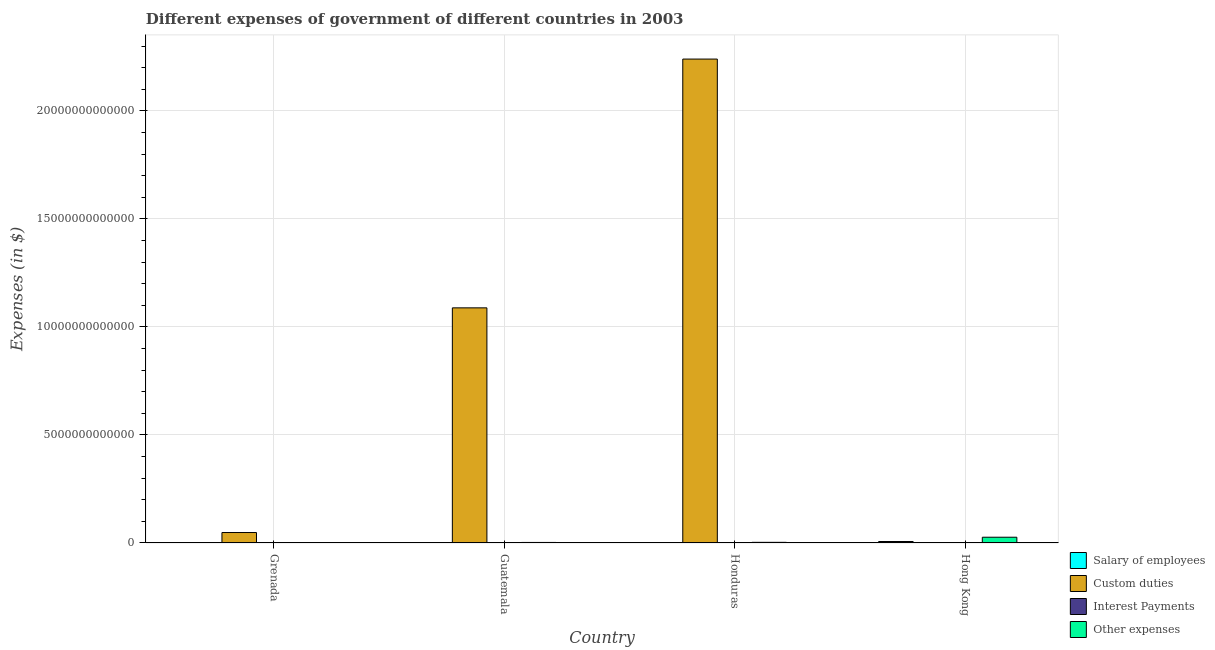How many groups of bars are there?
Offer a very short reply. 4. How many bars are there on the 3rd tick from the left?
Your response must be concise. 4. What is the label of the 4th group of bars from the left?
Ensure brevity in your answer.  Hong Kong. What is the amount spent on other expenses in Grenada?
Provide a succinct answer. 2.86e+08. Across all countries, what is the maximum amount spent on interest payments?
Provide a succinct answer. 2.21e+09. Across all countries, what is the minimum amount spent on other expenses?
Offer a very short reply. 2.86e+08. In which country was the amount spent on custom duties maximum?
Ensure brevity in your answer.  Honduras. In which country was the amount spent on other expenses minimum?
Keep it short and to the point. Grenada. What is the total amount spent on other expenses in the graph?
Offer a terse response. 3.22e+11. What is the difference between the amount spent on custom duties in Honduras and that in Hong Kong?
Give a very brief answer. 2.24e+13. What is the difference between the amount spent on interest payments in Hong Kong and the amount spent on custom duties in Guatemala?
Offer a very short reply. -1.09e+13. What is the average amount spent on other expenses per country?
Give a very brief answer. 8.05e+1. What is the difference between the amount spent on interest payments and amount spent on custom duties in Hong Kong?
Your answer should be very brief. 1.05e+07. What is the ratio of the amount spent on other expenses in Grenada to that in Guatemala?
Provide a succinct answer. 0.01. Is the amount spent on other expenses in Grenada less than that in Guatemala?
Offer a terse response. Yes. Is the difference between the amount spent on custom duties in Guatemala and Hong Kong greater than the difference between the amount spent on salary of employees in Guatemala and Hong Kong?
Your response must be concise. Yes. What is the difference between the highest and the second highest amount spent on custom duties?
Ensure brevity in your answer.  1.15e+13. What is the difference between the highest and the lowest amount spent on salary of employees?
Make the answer very short. 6.86e+1. What does the 3rd bar from the left in Honduras represents?
Your answer should be compact. Interest Payments. What does the 1st bar from the right in Hong Kong represents?
Ensure brevity in your answer.  Other expenses. Are all the bars in the graph horizontal?
Offer a very short reply. No. How many countries are there in the graph?
Your answer should be very brief. 4. What is the difference between two consecutive major ticks on the Y-axis?
Your answer should be compact. 5.00e+12. Are the values on the major ticks of Y-axis written in scientific E-notation?
Your answer should be very brief. No. Does the graph contain grids?
Offer a very short reply. Yes. Where does the legend appear in the graph?
Provide a succinct answer. Bottom right. How many legend labels are there?
Your response must be concise. 4. What is the title of the graph?
Provide a succinct answer. Different expenses of government of different countries in 2003. What is the label or title of the X-axis?
Your answer should be compact. Country. What is the label or title of the Y-axis?
Give a very brief answer. Expenses (in $). What is the Expenses (in $) of Salary of employees in Grenada?
Your answer should be compact. 1.30e+08. What is the Expenses (in $) in Custom duties in Grenada?
Ensure brevity in your answer.  4.85e+11. What is the Expenses (in $) in Interest Payments in Grenada?
Give a very brief answer. 6.31e+07. What is the Expenses (in $) of Other expenses in Grenada?
Keep it short and to the point. 2.86e+08. What is the Expenses (in $) of Salary of employees in Guatemala?
Offer a terse response. 6.75e+09. What is the Expenses (in $) in Custom duties in Guatemala?
Your answer should be very brief. 1.09e+13. What is the Expenses (in $) in Interest Payments in Guatemala?
Keep it short and to the point. 2.21e+09. What is the Expenses (in $) of Other expenses in Guatemala?
Ensure brevity in your answer.  2.50e+1. What is the Expenses (in $) in Salary of employees in Honduras?
Give a very brief answer. 1.51e+1. What is the Expenses (in $) in Custom duties in Honduras?
Make the answer very short. 2.24e+13. What is the Expenses (in $) of Interest Payments in Honduras?
Provide a short and direct response. 2.05e+09. What is the Expenses (in $) in Other expenses in Honduras?
Provide a short and direct response. 2.99e+1. What is the Expenses (in $) in Salary of employees in Hong Kong?
Give a very brief answer. 6.88e+1. What is the Expenses (in $) of Custom duties in Hong Kong?
Your answer should be compact. 2.45e+07. What is the Expenses (in $) in Interest Payments in Hong Kong?
Provide a short and direct response. 3.50e+07. What is the Expenses (in $) in Other expenses in Hong Kong?
Make the answer very short. 2.67e+11. Across all countries, what is the maximum Expenses (in $) of Salary of employees?
Keep it short and to the point. 6.88e+1. Across all countries, what is the maximum Expenses (in $) in Custom duties?
Your response must be concise. 2.24e+13. Across all countries, what is the maximum Expenses (in $) of Interest Payments?
Your answer should be very brief. 2.21e+09. Across all countries, what is the maximum Expenses (in $) of Other expenses?
Give a very brief answer. 2.67e+11. Across all countries, what is the minimum Expenses (in $) of Salary of employees?
Keep it short and to the point. 1.30e+08. Across all countries, what is the minimum Expenses (in $) in Custom duties?
Keep it short and to the point. 2.45e+07. Across all countries, what is the minimum Expenses (in $) in Interest Payments?
Your response must be concise. 3.50e+07. Across all countries, what is the minimum Expenses (in $) in Other expenses?
Give a very brief answer. 2.86e+08. What is the total Expenses (in $) in Salary of employees in the graph?
Keep it short and to the point. 9.08e+1. What is the total Expenses (in $) in Custom duties in the graph?
Your answer should be very brief. 3.38e+13. What is the total Expenses (in $) in Interest Payments in the graph?
Give a very brief answer. 4.36e+09. What is the total Expenses (in $) of Other expenses in the graph?
Provide a succinct answer. 3.22e+11. What is the difference between the Expenses (in $) in Salary of employees in Grenada and that in Guatemala?
Make the answer very short. -6.62e+09. What is the difference between the Expenses (in $) of Custom duties in Grenada and that in Guatemala?
Offer a terse response. -1.04e+13. What is the difference between the Expenses (in $) in Interest Payments in Grenada and that in Guatemala?
Your response must be concise. -2.14e+09. What is the difference between the Expenses (in $) in Other expenses in Grenada and that in Guatemala?
Provide a succinct answer. -2.47e+1. What is the difference between the Expenses (in $) of Salary of employees in Grenada and that in Honduras?
Ensure brevity in your answer.  -1.50e+1. What is the difference between the Expenses (in $) in Custom duties in Grenada and that in Honduras?
Keep it short and to the point. -2.19e+13. What is the difference between the Expenses (in $) in Interest Payments in Grenada and that in Honduras?
Ensure brevity in your answer.  -1.99e+09. What is the difference between the Expenses (in $) in Other expenses in Grenada and that in Honduras?
Offer a terse response. -2.96e+1. What is the difference between the Expenses (in $) in Salary of employees in Grenada and that in Hong Kong?
Your response must be concise. -6.86e+1. What is the difference between the Expenses (in $) in Custom duties in Grenada and that in Hong Kong?
Offer a very short reply. 4.85e+11. What is the difference between the Expenses (in $) in Interest Payments in Grenada and that in Hong Kong?
Provide a succinct answer. 2.81e+07. What is the difference between the Expenses (in $) in Other expenses in Grenada and that in Hong Kong?
Provide a short and direct response. -2.67e+11. What is the difference between the Expenses (in $) of Salary of employees in Guatemala and that in Honduras?
Give a very brief answer. -8.35e+09. What is the difference between the Expenses (in $) in Custom duties in Guatemala and that in Honduras?
Your response must be concise. -1.15e+13. What is the difference between the Expenses (in $) in Interest Payments in Guatemala and that in Honduras?
Provide a short and direct response. 1.54e+08. What is the difference between the Expenses (in $) in Other expenses in Guatemala and that in Honduras?
Your answer should be compact. -4.88e+09. What is the difference between the Expenses (in $) in Salary of employees in Guatemala and that in Hong Kong?
Provide a short and direct response. -6.20e+1. What is the difference between the Expenses (in $) of Custom duties in Guatemala and that in Hong Kong?
Ensure brevity in your answer.  1.09e+13. What is the difference between the Expenses (in $) of Interest Payments in Guatemala and that in Hong Kong?
Your answer should be compact. 2.17e+09. What is the difference between the Expenses (in $) of Other expenses in Guatemala and that in Hong Kong?
Provide a succinct answer. -2.42e+11. What is the difference between the Expenses (in $) of Salary of employees in Honduras and that in Hong Kong?
Make the answer very short. -5.37e+1. What is the difference between the Expenses (in $) of Custom duties in Honduras and that in Hong Kong?
Give a very brief answer. 2.24e+13. What is the difference between the Expenses (in $) in Interest Payments in Honduras and that in Hong Kong?
Offer a terse response. 2.02e+09. What is the difference between the Expenses (in $) in Other expenses in Honduras and that in Hong Kong?
Your answer should be compact. -2.37e+11. What is the difference between the Expenses (in $) in Salary of employees in Grenada and the Expenses (in $) in Custom duties in Guatemala?
Provide a succinct answer. -1.09e+13. What is the difference between the Expenses (in $) in Salary of employees in Grenada and the Expenses (in $) in Interest Payments in Guatemala?
Make the answer very short. -2.08e+09. What is the difference between the Expenses (in $) of Salary of employees in Grenada and the Expenses (in $) of Other expenses in Guatemala?
Offer a terse response. -2.48e+1. What is the difference between the Expenses (in $) in Custom duties in Grenada and the Expenses (in $) in Interest Payments in Guatemala?
Your response must be concise. 4.82e+11. What is the difference between the Expenses (in $) in Custom duties in Grenada and the Expenses (in $) in Other expenses in Guatemala?
Make the answer very short. 4.60e+11. What is the difference between the Expenses (in $) of Interest Payments in Grenada and the Expenses (in $) of Other expenses in Guatemala?
Provide a short and direct response. -2.49e+1. What is the difference between the Expenses (in $) in Salary of employees in Grenada and the Expenses (in $) in Custom duties in Honduras?
Make the answer very short. -2.24e+13. What is the difference between the Expenses (in $) in Salary of employees in Grenada and the Expenses (in $) in Interest Payments in Honduras?
Ensure brevity in your answer.  -1.92e+09. What is the difference between the Expenses (in $) in Salary of employees in Grenada and the Expenses (in $) in Other expenses in Honduras?
Provide a succinct answer. -2.97e+1. What is the difference between the Expenses (in $) in Custom duties in Grenada and the Expenses (in $) in Interest Payments in Honduras?
Give a very brief answer. 4.83e+11. What is the difference between the Expenses (in $) of Custom duties in Grenada and the Expenses (in $) of Other expenses in Honduras?
Your answer should be very brief. 4.55e+11. What is the difference between the Expenses (in $) of Interest Payments in Grenada and the Expenses (in $) of Other expenses in Honduras?
Provide a succinct answer. -2.98e+1. What is the difference between the Expenses (in $) in Salary of employees in Grenada and the Expenses (in $) in Custom duties in Hong Kong?
Keep it short and to the point. 1.06e+08. What is the difference between the Expenses (in $) of Salary of employees in Grenada and the Expenses (in $) of Interest Payments in Hong Kong?
Make the answer very short. 9.54e+07. What is the difference between the Expenses (in $) of Salary of employees in Grenada and the Expenses (in $) of Other expenses in Hong Kong?
Provide a succinct answer. -2.67e+11. What is the difference between the Expenses (in $) of Custom duties in Grenada and the Expenses (in $) of Interest Payments in Hong Kong?
Your answer should be compact. 4.85e+11. What is the difference between the Expenses (in $) in Custom duties in Grenada and the Expenses (in $) in Other expenses in Hong Kong?
Provide a short and direct response. 2.18e+11. What is the difference between the Expenses (in $) in Interest Payments in Grenada and the Expenses (in $) in Other expenses in Hong Kong?
Ensure brevity in your answer.  -2.67e+11. What is the difference between the Expenses (in $) in Salary of employees in Guatemala and the Expenses (in $) in Custom duties in Honduras?
Offer a very short reply. -2.24e+13. What is the difference between the Expenses (in $) in Salary of employees in Guatemala and the Expenses (in $) in Interest Payments in Honduras?
Your response must be concise. 4.70e+09. What is the difference between the Expenses (in $) in Salary of employees in Guatemala and the Expenses (in $) in Other expenses in Honduras?
Keep it short and to the point. -2.31e+1. What is the difference between the Expenses (in $) in Custom duties in Guatemala and the Expenses (in $) in Interest Payments in Honduras?
Make the answer very short. 1.09e+13. What is the difference between the Expenses (in $) of Custom duties in Guatemala and the Expenses (in $) of Other expenses in Honduras?
Offer a terse response. 1.09e+13. What is the difference between the Expenses (in $) in Interest Payments in Guatemala and the Expenses (in $) in Other expenses in Honduras?
Keep it short and to the point. -2.76e+1. What is the difference between the Expenses (in $) in Salary of employees in Guatemala and the Expenses (in $) in Custom duties in Hong Kong?
Ensure brevity in your answer.  6.73e+09. What is the difference between the Expenses (in $) of Salary of employees in Guatemala and the Expenses (in $) of Interest Payments in Hong Kong?
Provide a short and direct response. 6.72e+09. What is the difference between the Expenses (in $) of Salary of employees in Guatemala and the Expenses (in $) of Other expenses in Hong Kong?
Keep it short and to the point. -2.60e+11. What is the difference between the Expenses (in $) in Custom duties in Guatemala and the Expenses (in $) in Interest Payments in Hong Kong?
Offer a terse response. 1.09e+13. What is the difference between the Expenses (in $) of Custom duties in Guatemala and the Expenses (in $) of Other expenses in Hong Kong?
Your answer should be very brief. 1.06e+13. What is the difference between the Expenses (in $) in Interest Payments in Guatemala and the Expenses (in $) in Other expenses in Hong Kong?
Make the answer very short. -2.65e+11. What is the difference between the Expenses (in $) of Salary of employees in Honduras and the Expenses (in $) of Custom duties in Hong Kong?
Offer a terse response. 1.51e+1. What is the difference between the Expenses (in $) in Salary of employees in Honduras and the Expenses (in $) in Interest Payments in Hong Kong?
Ensure brevity in your answer.  1.51e+1. What is the difference between the Expenses (in $) in Salary of employees in Honduras and the Expenses (in $) in Other expenses in Hong Kong?
Keep it short and to the point. -2.52e+11. What is the difference between the Expenses (in $) of Custom duties in Honduras and the Expenses (in $) of Interest Payments in Hong Kong?
Offer a very short reply. 2.24e+13. What is the difference between the Expenses (in $) of Custom duties in Honduras and the Expenses (in $) of Other expenses in Hong Kong?
Give a very brief answer. 2.21e+13. What is the difference between the Expenses (in $) of Interest Payments in Honduras and the Expenses (in $) of Other expenses in Hong Kong?
Offer a terse response. -2.65e+11. What is the average Expenses (in $) in Salary of employees per country?
Your response must be concise. 2.27e+1. What is the average Expenses (in $) of Custom duties per country?
Ensure brevity in your answer.  8.44e+12. What is the average Expenses (in $) in Interest Payments per country?
Your response must be concise. 1.09e+09. What is the average Expenses (in $) in Other expenses per country?
Your answer should be very brief. 8.05e+1. What is the difference between the Expenses (in $) in Salary of employees and Expenses (in $) in Custom duties in Grenada?
Your answer should be very brief. -4.84e+11. What is the difference between the Expenses (in $) in Salary of employees and Expenses (in $) in Interest Payments in Grenada?
Give a very brief answer. 6.73e+07. What is the difference between the Expenses (in $) in Salary of employees and Expenses (in $) in Other expenses in Grenada?
Make the answer very short. -1.55e+08. What is the difference between the Expenses (in $) in Custom duties and Expenses (in $) in Interest Payments in Grenada?
Make the answer very short. 4.85e+11. What is the difference between the Expenses (in $) in Custom duties and Expenses (in $) in Other expenses in Grenada?
Your answer should be very brief. 4.84e+11. What is the difference between the Expenses (in $) in Interest Payments and Expenses (in $) in Other expenses in Grenada?
Your answer should be very brief. -2.23e+08. What is the difference between the Expenses (in $) in Salary of employees and Expenses (in $) in Custom duties in Guatemala?
Provide a short and direct response. -1.09e+13. What is the difference between the Expenses (in $) of Salary of employees and Expenses (in $) of Interest Payments in Guatemala?
Ensure brevity in your answer.  4.54e+09. What is the difference between the Expenses (in $) in Salary of employees and Expenses (in $) in Other expenses in Guatemala?
Provide a succinct answer. -1.82e+1. What is the difference between the Expenses (in $) in Custom duties and Expenses (in $) in Interest Payments in Guatemala?
Keep it short and to the point. 1.09e+13. What is the difference between the Expenses (in $) of Custom duties and Expenses (in $) of Other expenses in Guatemala?
Ensure brevity in your answer.  1.09e+13. What is the difference between the Expenses (in $) in Interest Payments and Expenses (in $) in Other expenses in Guatemala?
Ensure brevity in your answer.  -2.28e+1. What is the difference between the Expenses (in $) in Salary of employees and Expenses (in $) in Custom duties in Honduras?
Ensure brevity in your answer.  -2.24e+13. What is the difference between the Expenses (in $) of Salary of employees and Expenses (in $) of Interest Payments in Honduras?
Your answer should be very brief. 1.30e+1. What is the difference between the Expenses (in $) in Salary of employees and Expenses (in $) in Other expenses in Honduras?
Your answer should be very brief. -1.48e+1. What is the difference between the Expenses (in $) in Custom duties and Expenses (in $) in Interest Payments in Honduras?
Provide a short and direct response. 2.24e+13. What is the difference between the Expenses (in $) of Custom duties and Expenses (in $) of Other expenses in Honduras?
Your response must be concise. 2.24e+13. What is the difference between the Expenses (in $) of Interest Payments and Expenses (in $) of Other expenses in Honduras?
Ensure brevity in your answer.  -2.78e+1. What is the difference between the Expenses (in $) in Salary of employees and Expenses (in $) in Custom duties in Hong Kong?
Make the answer very short. 6.87e+1. What is the difference between the Expenses (in $) in Salary of employees and Expenses (in $) in Interest Payments in Hong Kong?
Your answer should be very brief. 6.87e+1. What is the difference between the Expenses (in $) of Salary of employees and Expenses (in $) of Other expenses in Hong Kong?
Make the answer very short. -1.98e+11. What is the difference between the Expenses (in $) in Custom duties and Expenses (in $) in Interest Payments in Hong Kong?
Offer a very short reply. -1.05e+07. What is the difference between the Expenses (in $) in Custom duties and Expenses (in $) in Other expenses in Hong Kong?
Make the answer very short. -2.67e+11. What is the difference between the Expenses (in $) of Interest Payments and Expenses (in $) of Other expenses in Hong Kong?
Your response must be concise. -2.67e+11. What is the ratio of the Expenses (in $) of Salary of employees in Grenada to that in Guatemala?
Provide a succinct answer. 0.02. What is the ratio of the Expenses (in $) of Custom duties in Grenada to that in Guatemala?
Make the answer very short. 0.04. What is the ratio of the Expenses (in $) in Interest Payments in Grenada to that in Guatemala?
Your answer should be compact. 0.03. What is the ratio of the Expenses (in $) in Other expenses in Grenada to that in Guatemala?
Your response must be concise. 0.01. What is the ratio of the Expenses (in $) in Salary of employees in Grenada to that in Honduras?
Provide a short and direct response. 0.01. What is the ratio of the Expenses (in $) in Custom duties in Grenada to that in Honduras?
Provide a succinct answer. 0.02. What is the ratio of the Expenses (in $) of Interest Payments in Grenada to that in Honduras?
Keep it short and to the point. 0.03. What is the ratio of the Expenses (in $) in Other expenses in Grenada to that in Honduras?
Your response must be concise. 0.01. What is the ratio of the Expenses (in $) in Salary of employees in Grenada to that in Hong Kong?
Your answer should be compact. 0. What is the ratio of the Expenses (in $) in Custom duties in Grenada to that in Hong Kong?
Your answer should be compact. 1.98e+04. What is the ratio of the Expenses (in $) of Interest Payments in Grenada to that in Hong Kong?
Offer a very short reply. 1.8. What is the ratio of the Expenses (in $) of Other expenses in Grenada to that in Hong Kong?
Give a very brief answer. 0. What is the ratio of the Expenses (in $) in Salary of employees in Guatemala to that in Honduras?
Ensure brevity in your answer.  0.45. What is the ratio of the Expenses (in $) in Custom duties in Guatemala to that in Honduras?
Provide a succinct answer. 0.49. What is the ratio of the Expenses (in $) of Interest Payments in Guatemala to that in Honduras?
Give a very brief answer. 1.08. What is the ratio of the Expenses (in $) of Other expenses in Guatemala to that in Honduras?
Keep it short and to the point. 0.84. What is the ratio of the Expenses (in $) in Salary of employees in Guatemala to that in Hong Kong?
Provide a short and direct response. 0.1. What is the ratio of the Expenses (in $) in Custom duties in Guatemala to that in Hong Kong?
Make the answer very short. 4.45e+05. What is the ratio of the Expenses (in $) of Interest Payments in Guatemala to that in Hong Kong?
Offer a terse response. 63.07. What is the ratio of the Expenses (in $) in Other expenses in Guatemala to that in Hong Kong?
Keep it short and to the point. 0.09. What is the ratio of the Expenses (in $) of Salary of employees in Honduras to that in Hong Kong?
Give a very brief answer. 0.22. What is the ratio of the Expenses (in $) in Custom duties in Honduras to that in Hong Kong?
Offer a very short reply. 9.15e+05. What is the ratio of the Expenses (in $) in Interest Payments in Honduras to that in Hong Kong?
Offer a terse response. 58.66. What is the ratio of the Expenses (in $) in Other expenses in Honduras to that in Hong Kong?
Offer a very short reply. 0.11. What is the difference between the highest and the second highest Expenses (in $) of Salary of employees?
Offer a terse response. 5.37e+1. What is the difference between the highest and the second highest Expenses (in $) of Custom duties?
Your response must be concise. 1.15e+13. What is the difference between the highest and the second highest Expenses (in $) of Interest Payments?
Keep it short and to the point. 1.54e+08. What is the difference between the highest and the second highest Expenses (in $) in Other expenses?
Your answer should be compact. 2.37e+11. What is the difference between the highest and the lowest Expenses (in $) in Salary of employees?
Provide a succinct answer. 6.86e+1. What is the difference between the highest and the lowest Expenses (in $) in Custom duties?
Give a very brief answer. 2.24e+13. What is the difference between the highest and the lowest Expenses (in $) of Interest Payments?
Your response must be concise. 2.17e+09. What is the difference between the highest and the lowest Expenses (in $) of Other expenses?
Your answer should be compact. 2.67e+11. 